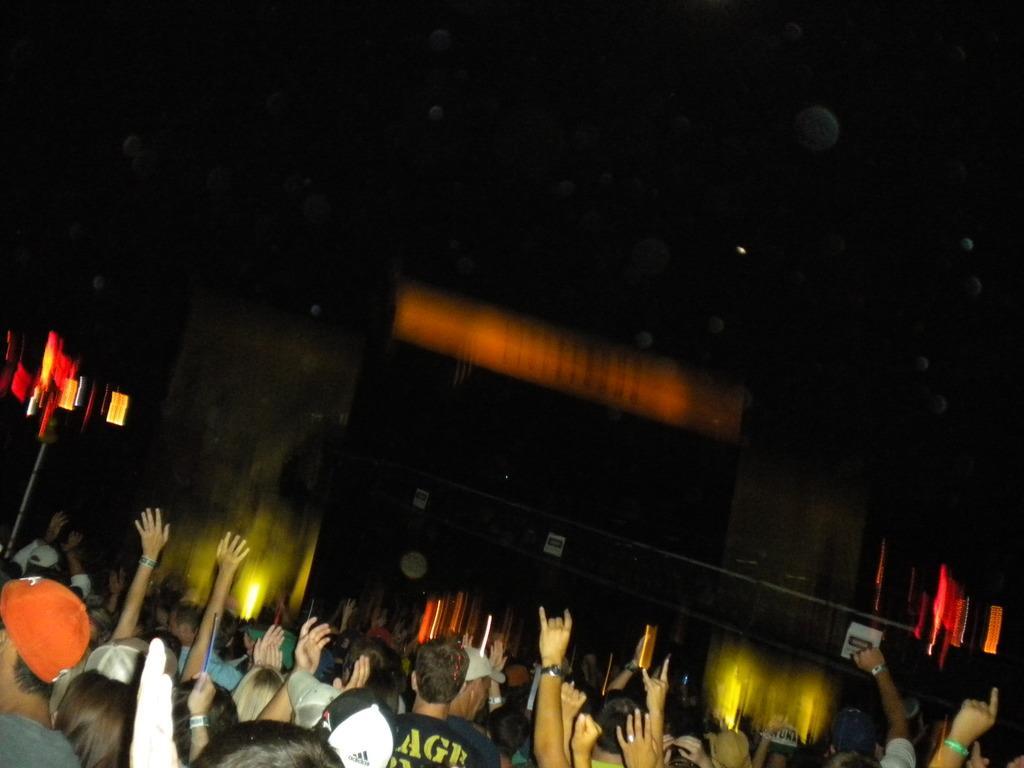In one or two sentences, can you explain what this image depicts? This picture seems to be clicked outside. In the foreground we can see the group of persons seems to be standing. The background of the image is blurry and we can see the buildings, lights and many other objects in the background. 